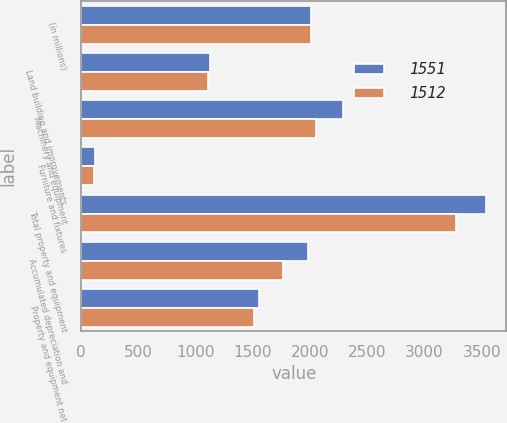<chart> <loc_0><loc_0><loc_500><loc_500><stacked_bar_chart><ecel><fcel>(in millions)<fcel>Land building and improvements<fcel>Machinery and equipment<fcel>Furniture and fixtures<fcel>Total property and equipment<fcel>Accumulated depreciation and<fcel>Property and equipment net<nl><fcel>1551<fcel>2012<fcel>1126<fcel>2291<fcel>120<fcel>3537<fcel>1986<fcel>1551<nl><fcel>1512<fcel>2011<fcel>1105<fcel>2055<fcel>114<fcel>3274<fcel>1762<fcel>1512<nl></chart> 